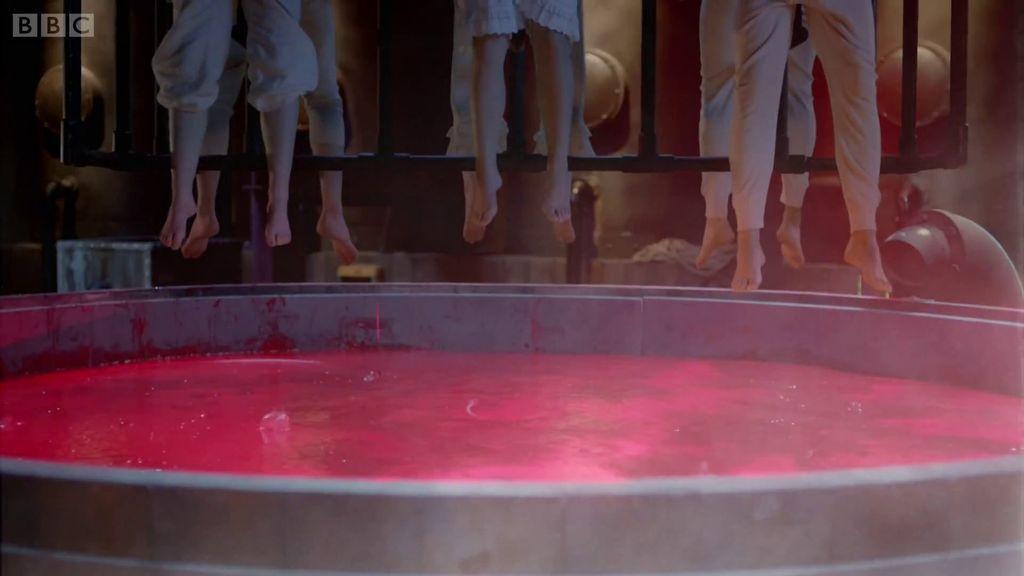Could you give a brief overview of what you see in this image? At the bottom of the image there is a circular container with red color liquid in it. At the top of the image there are persons legs. There is a railing. In the background of the image there is wall. There are pipes. 